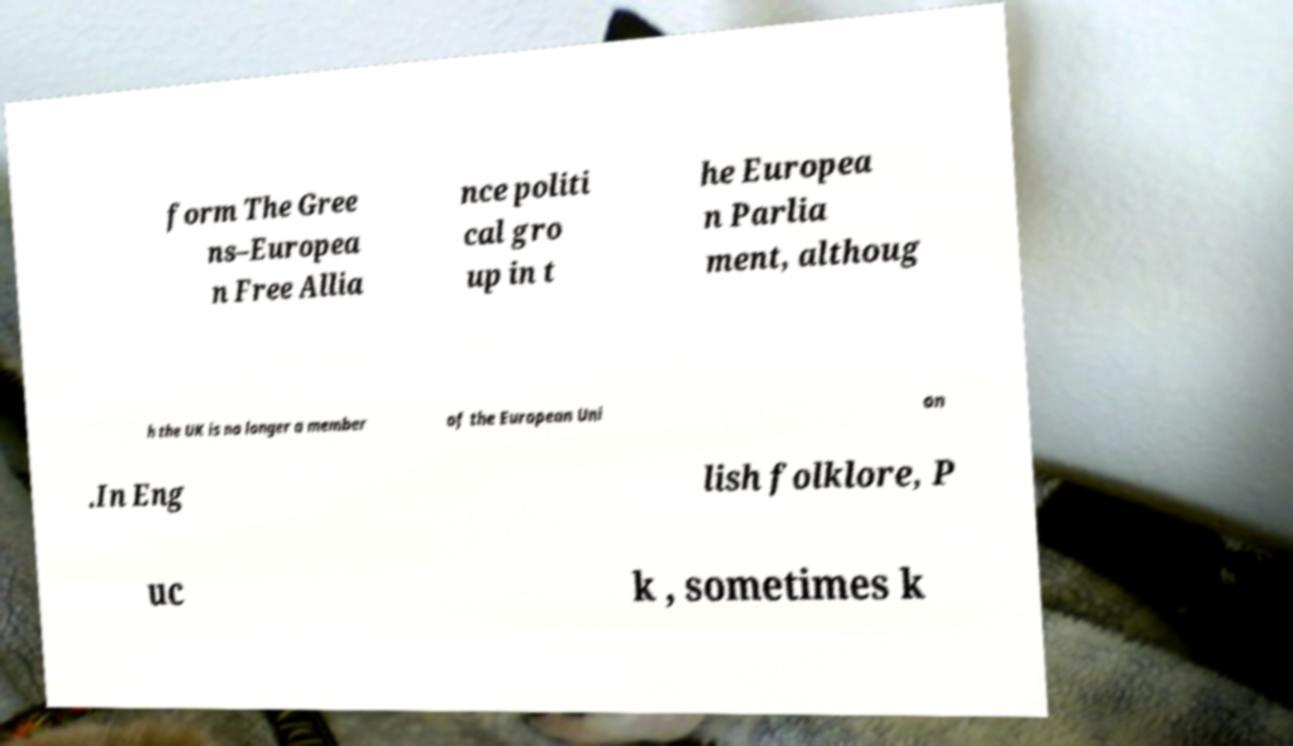For documentation purposes, I need the text within this image transcribed. Could you provide that? form The Gree ns–Europea n Free Allia nce politi cal gro up in t he Europea n Parlia ment, althoug h the UK is no longer a member of the European Uni on .In Eng lish folklore, P uc k , sometimes k 